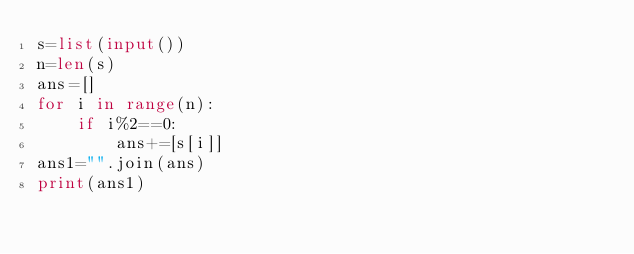Convert code to text. <code><loc_0><loc_0><loc_500><loc_500><_Python_>s=list(input())
n=len(s)
ans=[]
for i in range(n):
    if i%2==0:
        ans+=[s[i]]
ans1="".join(ans)
print(ans1)</code> 